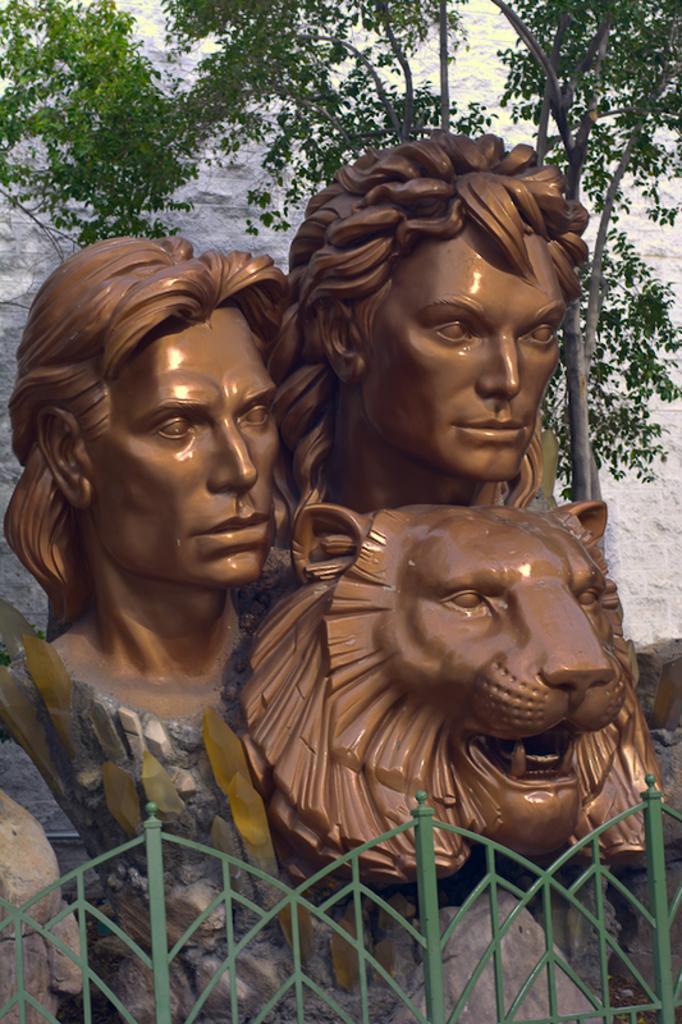Could you give a brief overview of what you see in this image? In this picture there are sculptures of a man and woman and there is a sculpture of a lion. In the foreground there is a railing. Behind the railing there are rocks and there is a tree. 